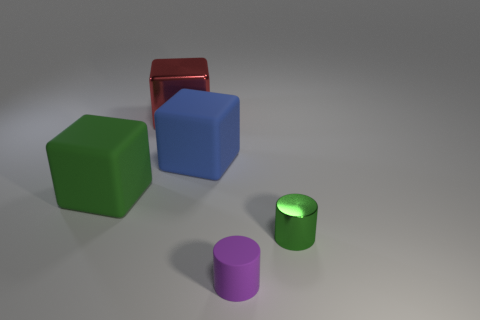How many blocks are large matte things or big green objects?
Your response must be concise. 2. What number of other objects are the same material as the big green thing?
Make the answer very short. 2. What is the shape of the shiny object that is on the right side of the purple matte cylinder?
Give a very brief answer. Cylinder. The tiny cylinder behind the cylinder in front of the small shiny thing is made of what material?
Give a very brief answer. Metal. Are there more red metallic things that are right of the small green object than blue cylinders?
Ensure brevity in your answer.  No. How many other objects are there of the same color as the tiny shiny cylinder?
Offer a terse response. 1. There is a blue thing that is the same size as the red thing; what is its shape?
Your answer should be very brief. Cube. How many green rubber things are on the right side of the rubber block to the right of the metallic object that is behind the blue thing?
Give a very brief answer. 0. How many rubber objects are large blue things or large gray balls?
Offer a terse response. 1. There is a object that is both in front of the blue rubber cube and behind the metallic cylinder; what color is it?
Your response must be concise. Green. 